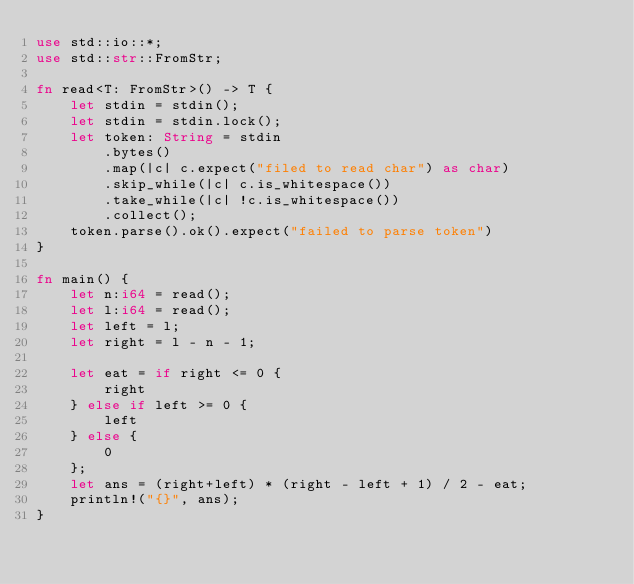<code> <loc_0><loc_0><loc_500><loc_500><_Rust_>use std::io::*;
use std::str::FromStr;

fn read<T: FromStr>() -> T {
    let stdin = stdin();
    let stdin = stdin.lock();
    let token: String = stdin
        .bytes()
        .map(|c| c.expect("filed to read char") as char)
        .skip_while(|c| c.is_whitespace())
        .take_while(|c| !c.is_whitespace())
        .collect();
    token.parse().ok().expect("failed to parse token")
}

fn main() {
    let n:i64 = read();
    let l:i64 = read();
    let left = l;
    let right = l - n - 1;

    let eat = if right <= 0 {
        right
    } else if left >= 0 {
        left
    } else {
        0
    };
    let ans = (right+left) * (right - left + 1) / 2 - eat;
    println!("{}", ans);
}</code> 